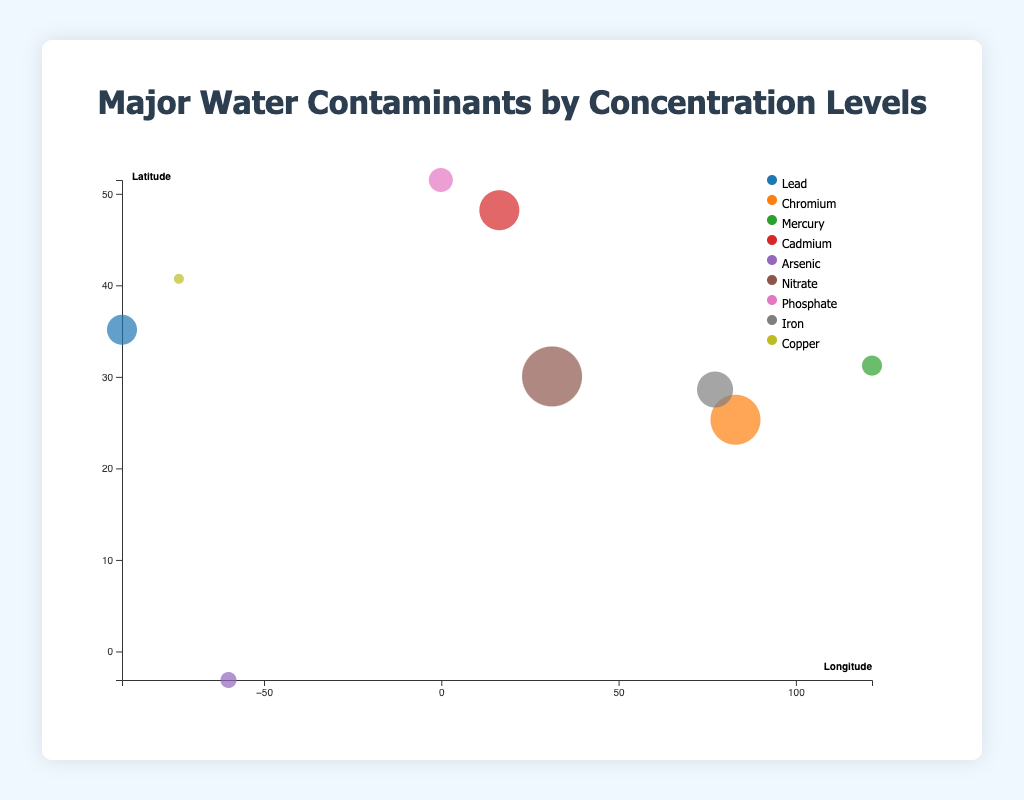What is the main title of the chart? The main title of the chart is located at the top center of the figure.
Answer: Major Water Contaminants by Concentration Levels How many different water contaminants are displayed in the chart? By examining the color legend at the right side of the figure, we can count the distinct colors representing each contaminant.
Answer: 9 Which river has the highest concentration of contaminants? By looking at the size of the bubbles, the largest bubble represents the highest concentration, which in this case is the Nile River with Nitrate contaminant.
Answer: Nile River What are the x and y axes of the chart representing? The x-axis represents the longitude, and the y-axis represents the latitude of the water bodies. These are specified by the axis labels.
Answer: Longitude and Latitude Which contaminant is found in the Thames River and at what concentration? By locating the bubble for the Thames River and referring to the tooltip that appears, we can see the contaminant and concentration.
Answer: Phosphate, 12 ppb Which water body is located at the coordinates 31.2304 latitude and 121.4737 longitude? By correlating the plotted points on the graph to these coordinates, we find the Yangtze River.
Answer: Yangtze River Compare the concentration of Mercury in the Yangtze River with Lead in the Mississippi River. Which is higher? By looking at the size of the respective bubbles representing each contaminant in both rivers, we can see that Lead (15 ppb) in the Mississippi River has a higher concentration than Mercury (10 ppb) in the Yangtze River.
Answer: Lead in the Mississippi River Which river is associated with a contaminant concentration of 8 ppb, and what is the contaminant? By examining the size of the bubbles and matching it with the tooltip information, we identify the Amazon River with Arsenic contaminant.
Answer: Amazon River, Arsenic How many rivers have a contaminant concentration greater than 15 ppb? By identifying bubbles that are larger than those representing 15 ppb (like the Mississippi River), we count the rivers with higher concentrations. They are the Ganges River, Nile River, Danube River, and Yamuna River.
Answer: 4 If you wanted to find the location with the highest concentration of Cadmium, which water body would you refer to? By finding the bubble color that matches the legend for Cadmium and the largest bubble among them, we locate the Danube River.
Answer: Danube River 